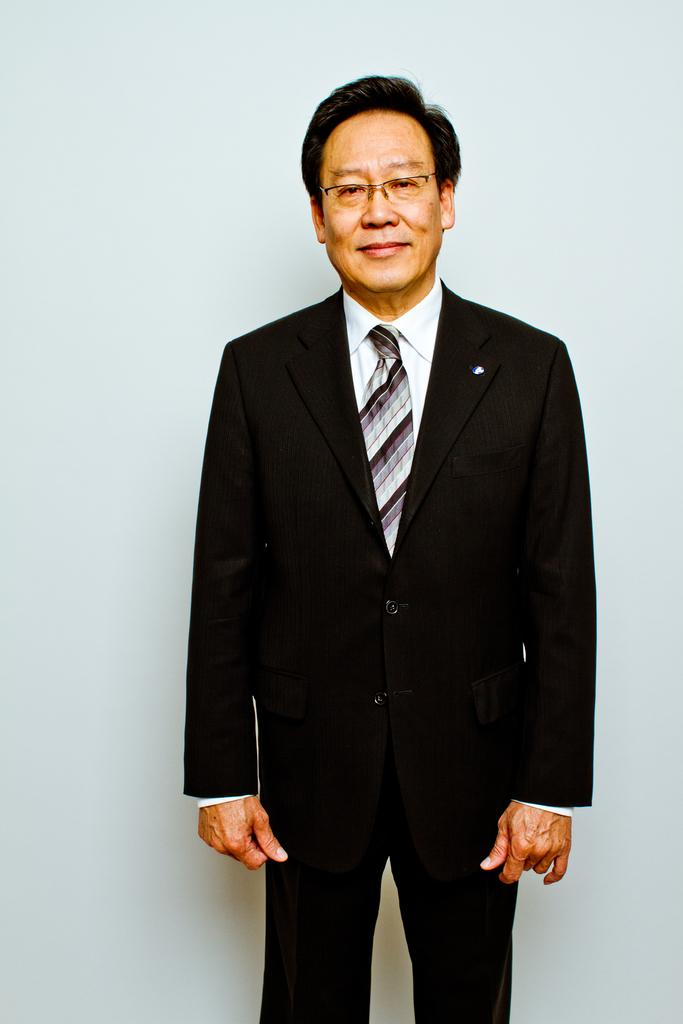What is the main subject of the image? There is a person in the image. What is the person's facial expression? The person is smiling. What can be seen behind the person? There is a wall behind the person. What type of argument is taking place in the image? There is no argument present in the image; the person is smiling. Can you see any boats or ships in the image? There is no harbor or any boats or ships visible in the image. 